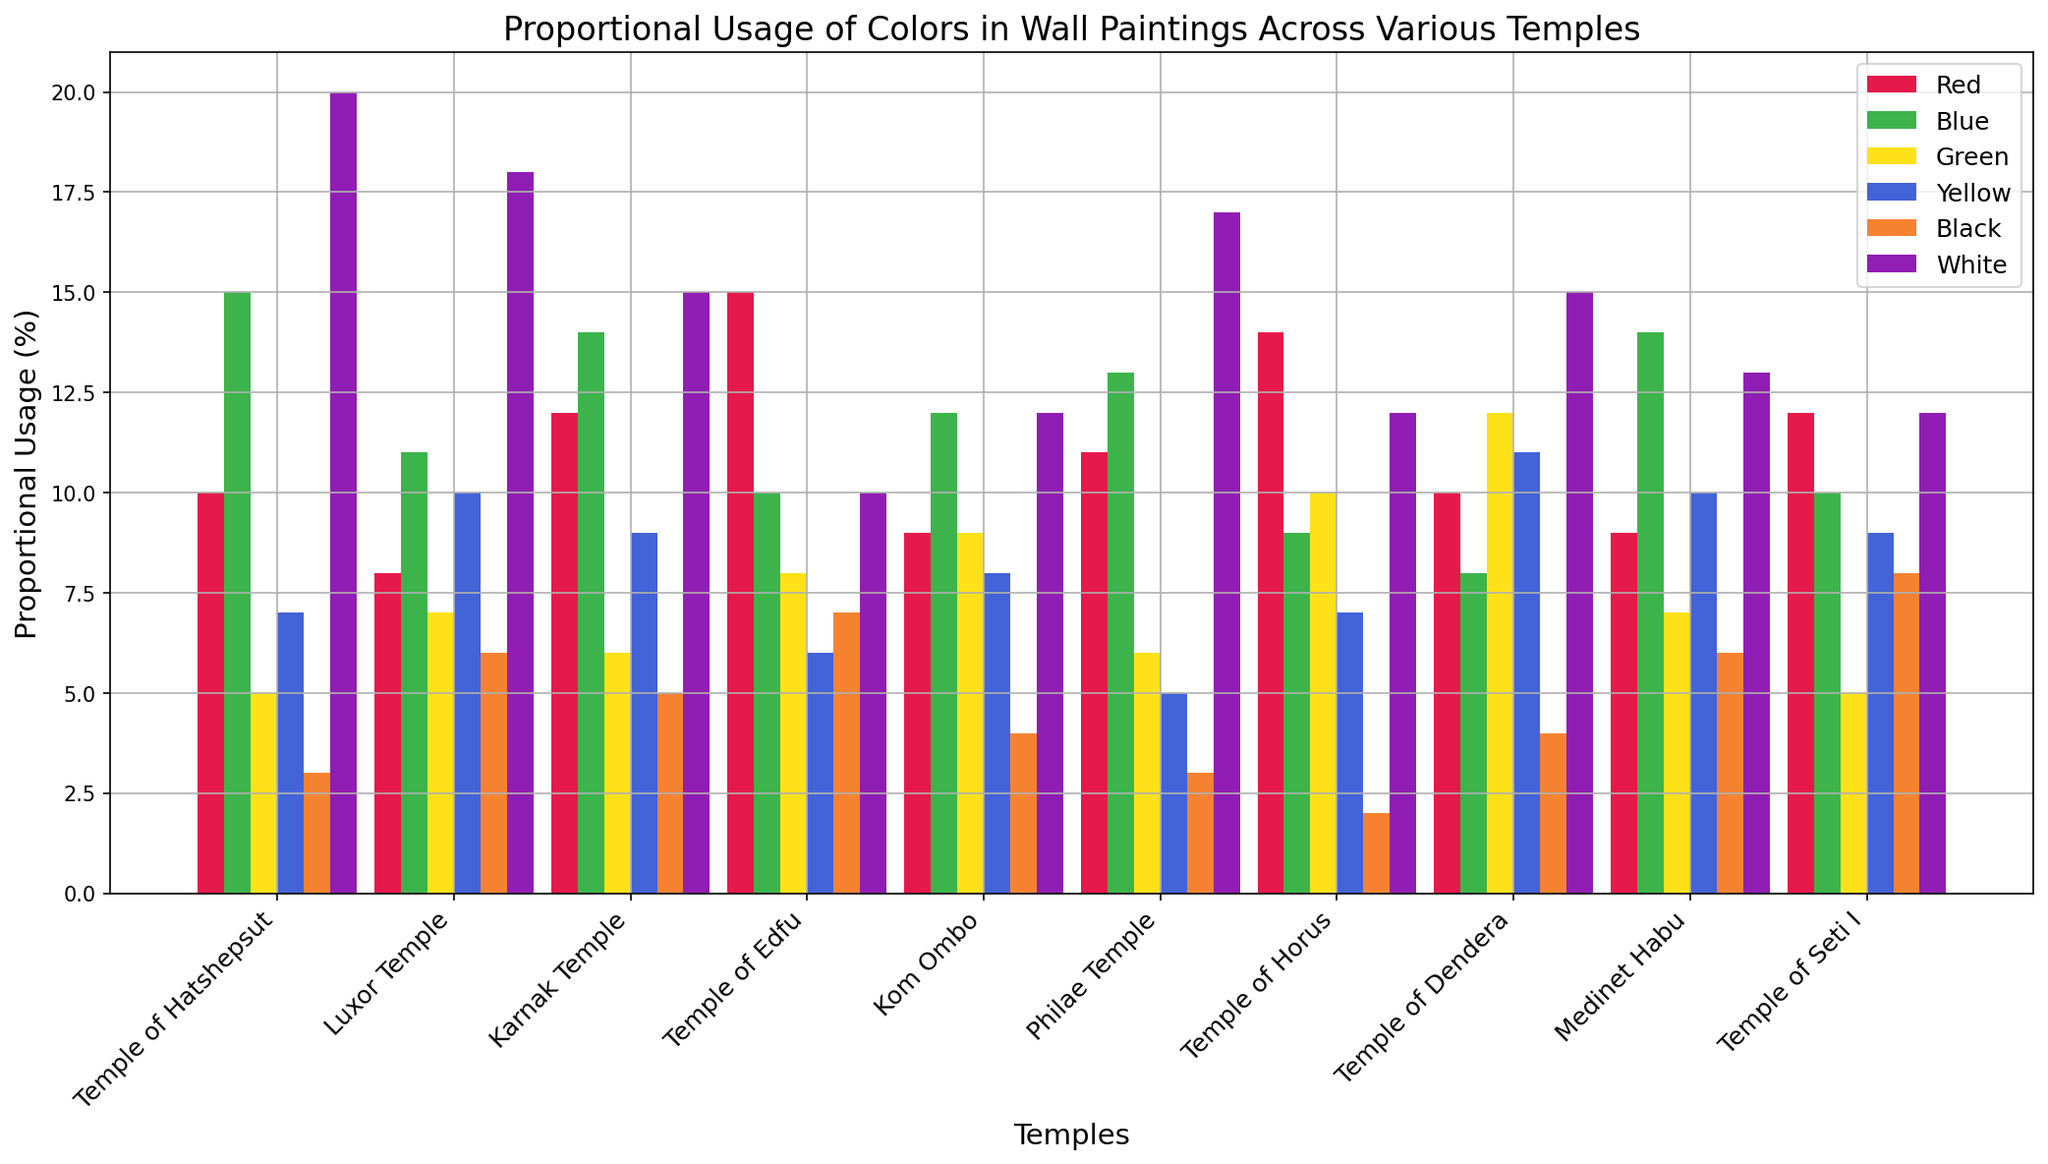What temple shows the highest proportional usage of the color red? By examining the heights of the red bars in the chart, it's clear that the Temple of Edfu, with the tallest red bar, has the highest usage of red.
Answer: Temple of Edfu Which temple has the lowest usage of white? By comparing the heights of the white bars across all temples, the Temple of Edfu shows the shortest white bar.
Answer: Temple of Edfu Compare the usage of green and blue in Kom Ombo. Which color is used more? In Kom Ombo, the height of the green bar is taller than the blue bar. This indicates that green is used more than blue.
Answer: Green Which temples show an equal usage of the color black? By examining the bars for black, both Luxor Temple and Medinet Habu show bars of the same height.
Answer: Luxor Temple and Medinet Habu What's the total usage of red and yellow combined in Karnak Temple? In Karnak Temple, the red bar is at 12, and the yellow bar is at 9. Adding these together, we get 12 + 9 = 21.
Answer: 21 Which color is used most in the Temple of Dendera? By looking at the chart for the Temple of Dendera, the tallest bar corresponds to the color green.
Answer: Green How does the usage of blue in the Temple of Horus compare to the usage in the Temple of Seti I? Comparing the two blue bars, the blue bar for the Temple of Horus is shorter than the one for the Temple of Seti I.
Answer: Temple of Seti I What’s the average usage of yellow across all the temples? Sum all the yellow values and divide by the number of temples (7 + 10 + 9 + 6 + 8 + 5 + 7 + 11 + 10 + 9). The total is 82, and there are 10 temples, so the average is 82/10 = 8.2.
Answer: 8.2 Which temple shows the most balanced usage of colors? By examining the chart, the Temple of Kom Ombo shows bars of relatively similar heights across all colors, indicating the most balanced usage.
Answer: Kom Ombo 